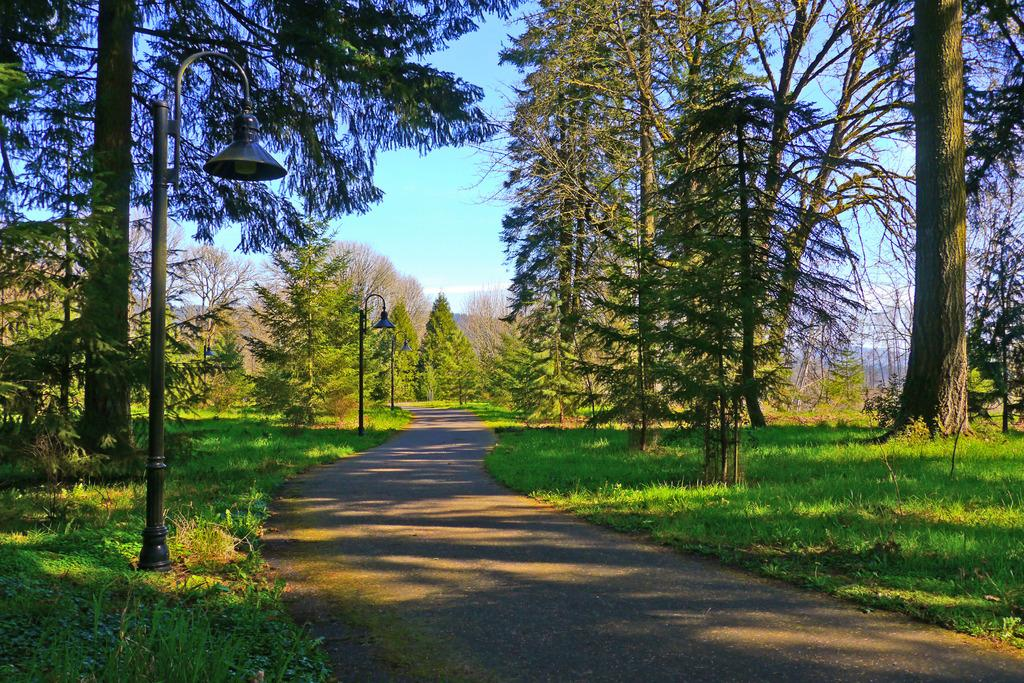What type of vegetation is present in the image? There are many trees in the image. How are the trees arranged in the image? The trees are planted. What type of artificial lighting is present in the image? There are street lights in the image. What type of ground cover is present in the image? There is grass in the image. What type of path is present in the image? There is a walkway in the image. What can be seen in the background of the image? The sky is visible in the background of the image. What type of baby is being cooked in the image? There is no baby present in the image, nor is there any indication of cooking. 